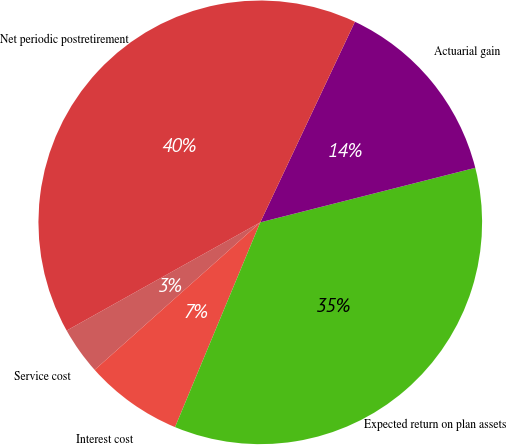Convert chart to OTSL. <chart><loc_0><loc_0><loc_500><loc_500><pie_chart><fcel>Service cost<fcel>Interest cost<fcel>Expected return on plan assets<fcel>Actuarial gain<fcel>Net periodic postretirement<nl><fcel>3.47%<fcel>7.14%<fcel>35.23%<fcel>14.03%<fcel>40.13%<nl></chart> 